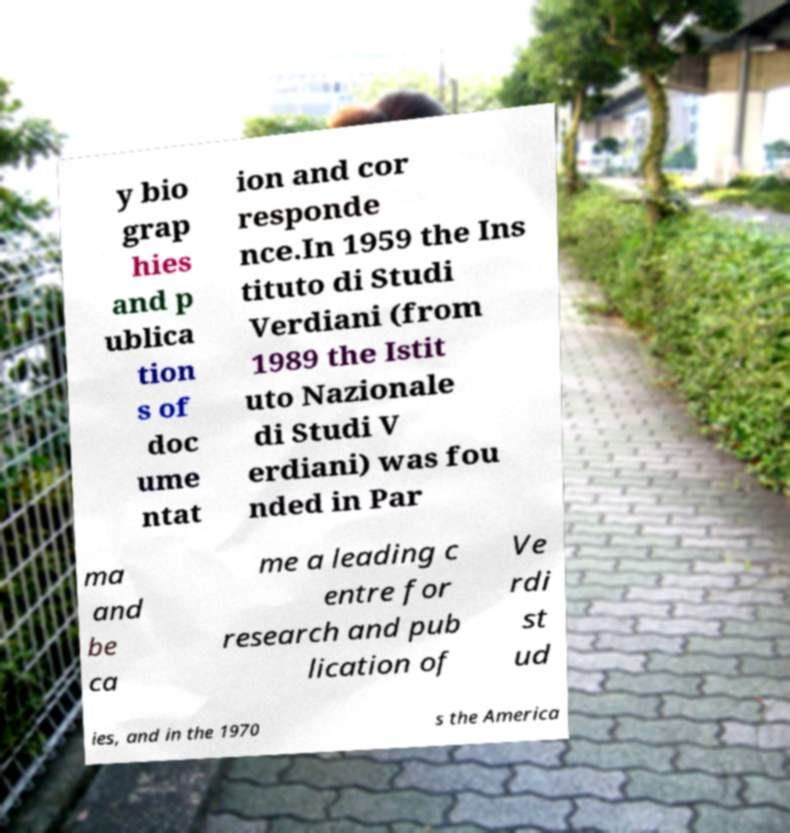What messages or text are displayed in this image? I need them in a readable, typed format. y bio grap hies and p ublica tion s of doc ume ntat ion and cor responde nce.In 1959 the Ins tituto di Studi Verdiani (from 1989 the Istit uto Nazionale di Studi V erdiani) was fou nded in Par ma and be ca me a leading c entre for research and pub lication of Ve rdi st ud ies, and in the 1970 s the America 